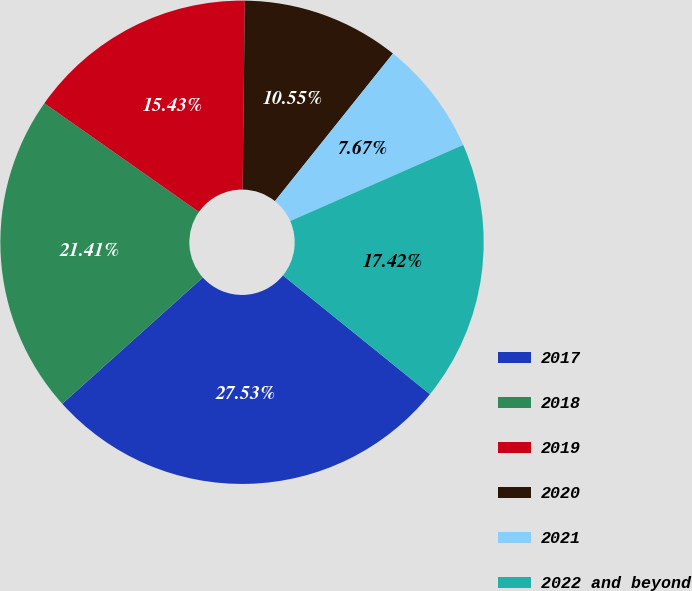<chart> <loc_0><loc_0><loc_500><loc_500><pie_chart><fcel>2017<fcel>2018<fcel>2019<fcel>2020<fcel>2021<fcel>2022 and beyond<nl><fcel>27.53%<fcel>21.41%<fcel>15.43%<fcel>10.55%<fcel>7.67%<fcel>17.42%<nl></chart> 